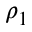<formula> <loc_0><loc_0><loc_500><loc_500>\rho _ { 1 }</formula> 